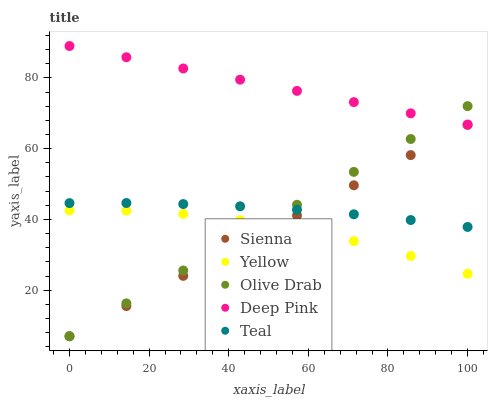Does Sienna have the minimum area under the curve?
Answer yes or no. Yes. Does Deep Pink have the maximum area under the curve?
Answer yes or no. Yes. Does Teal have the minimum area under the curve?
Answer yes or no. No. Does Teal have the maximum area under the curve?
Answer yes or no. No. Is Sienna the smoothest?
Answer yes or no. Yes. Is Yellow the roughest?
Answer yes or no. Yes. Is Deep Pink the smoothest?
Answer yes or no. No. Is Deep Pink the roughest?
Answer yes or no. No. Does Sienna have the lowest value?
Answer yes or no. Yes. Does Teal have the lowest value?
Answer yes or no. No. Does Deep Pink have the highest value?
Answer yes or no. Yes. Does Teal have the highest value?
Answer yes or no. No. Is Sienna less than Deep Pink?
Answer yes or no. Yes. Is Deep Pink greater than Yellow?
Answer yes or no. Yes. Does Sienna intersect Yellow?
Answer yes or no. Yes. Is Sienna less than Yellow?
Answer yes or no. No. Is Sienna greater than Yellow?
Answer yes or no. No. Does Sienna intersect Deep Pink?
Answer yes or no. No. 